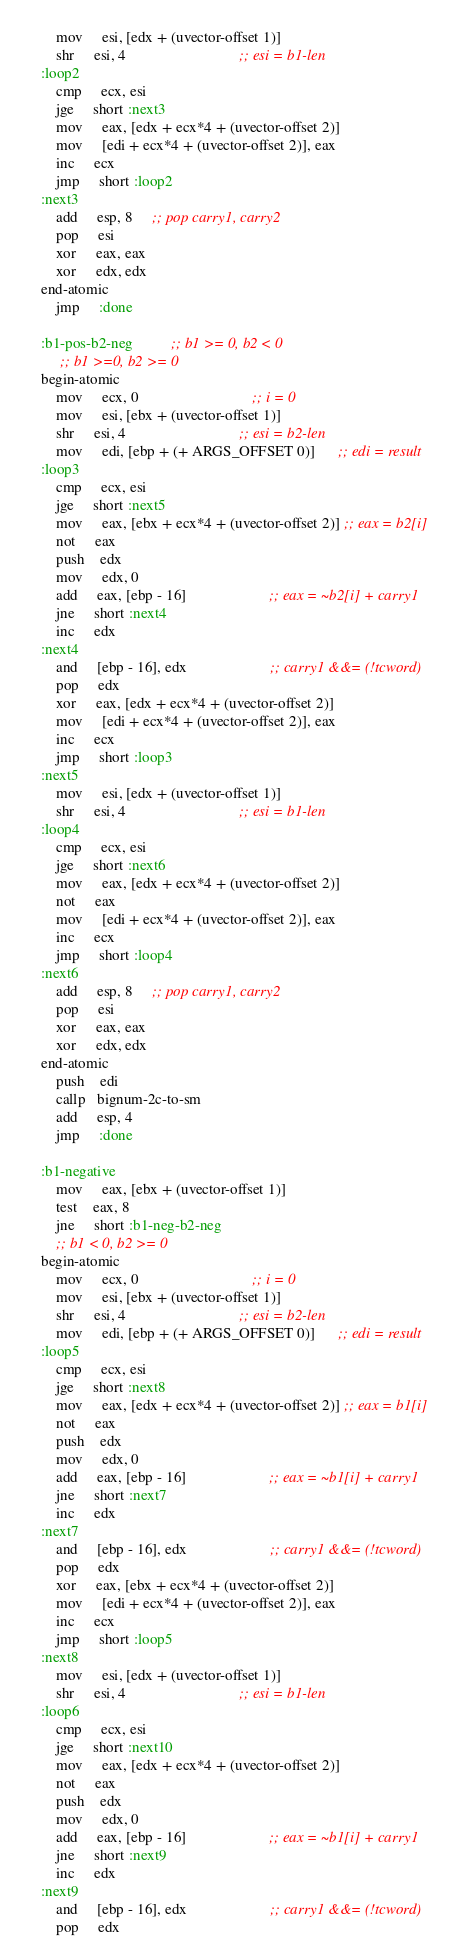Convert code to text. <code><loc_0><loc_0><loc_500><loc_500><_Lisp_>        mov     esi, [edx + (uvector-offset 1)]
        shr     esi, 4                              ;; esi = b1-len
    :loop2  
        cmp     ecx, esi
        jge     short :next3
        mov     eax, [edx + ecx*4 + (uvector-offset 2)]
        mov     [edi + ecx*4 + (uvector-offset 2)], eax 
        inc     ecx
        jmp     short :loop2                      
    :next3
        add     esp, 8     ;; pop carry1, carry2
        pop     esi
        xor     eax, eax
        xor     edx, edx
    end-atomic
        jmp     :done
    
    :b1-pos-b2-neg          ;; b1 >= 0, b2 < 0
         ;; b1 >=0, b2 >= 0
    begin-atomic
        mov     ecx, 0                              ;; i = 0
        mov     esi, [ebx + (uvector-offset 1)]
        shr     esi, 4                              ;; esi = b2-len
        mov     edi, [ebp + (+ ARGS_OFFSET 0)]      ;; edi = result
    :loop3
        cmp     ecx, esi
        jge     short :next5
        mov     eax, [ebx + ecx*4 + (uvector-offset 2)] ;; eax = b2[i]
        not     eax
        push    edx
        mov     edx, 0
        add     eax, [ebp - 16]                      ;; eax = ~b2[i] + carry1
        jne     short :next4
        inc     edx
    :next4
        and     [ebp - 16], edx                      ;; carry1 &&= (!tcword)
        pop     edx
        xor     eax, [edx + ecx*4 + (uvector-offset 2)]
        mov     [edi + ecx*4 + (uvector-offset 2)], eax
        inc     ecx
        jmp     short :loop3
    :next5
        mov     esi, [edx + (uvector-offset 1)]
        shr     esi, 4                              ;; esi = b1-len
    :loop4  
        cmp     ecx, esi
        jge     short :next6
        mov     eax, [edx + ecx*4 + (uvector-offset 2)]
        not     eax
        mov     [edi + ecx*4 + (uvector-offset 2)], eax 
        inc     ecx
        jmp     short :loop4                      
    :next6
        add     esp, 8     ;; pop carry1, carry2
        pop     esi
        xor     eax, eax
        xor     edx, edx
    end-atomic
        push    edi
        callp   bignum-2c-to-sm
        add     esp, 4
        jmp     :done
    
    :b1-negative 
        mov     eax, [ebx + (uvector-offset 1)]
        test    eax, 8
        jne     short :b1-neg-b2-neg    
        ;; b1 < 0, b2 >= 0 
    begin-atomic
        mov     ecx, 0                              ;; i = 0
        mov     esi, [ebx + (uvector-offset 1)]
        shr     esi, 4                              ;; esi = b2-len
        mov     edi, [ebp + (+ ARGS_OFFSET 0)]      ;; edi = result
    :loop5
        cmp     ecx, esi
        jge     short :next8
        mov     eax, [edx + ecx*4 + (uvector-offset 2)] ;; eax = b1[i]
        not     eax
        push    edx
        mov     edx, 0
        add     eax, [ebp - 16]                      ;; eax = ~b1[i] + carry1
        jne     short :next7
        inc     edx
    :next7
        and     [ebp - 16], edx                      ;; carry1 &&= (!tcword)
        pop     edx
        xor     eax, [ebx + ecx*4 + (uvector-offset 2)]
        mov     [edi + ecx*4 + (uvector-offset 2)], eax
        inc     ecx
        jmp     short :loop5
    :next8
        mov     esi, [edx + (uvector-offset 1)]
        shr     esi, 4                              ;; esi = b1-len
    :loop6  
        cmp     ecx, esi
        jge     short :next10
        mov     eax, [edx + ecx*4 + (uvector-offset 2)]
        not     eax
        push    edx
        mov     edx, 0
        add     eax, [ebp - 16]                      ;; eax = ~b1[i] + carry1
        jne     short :next9
        inc     edx
    :next9
        and     [ebp - 16], edx                      ;; carry1 &&= (!tcword)
        pop     edx</code> 